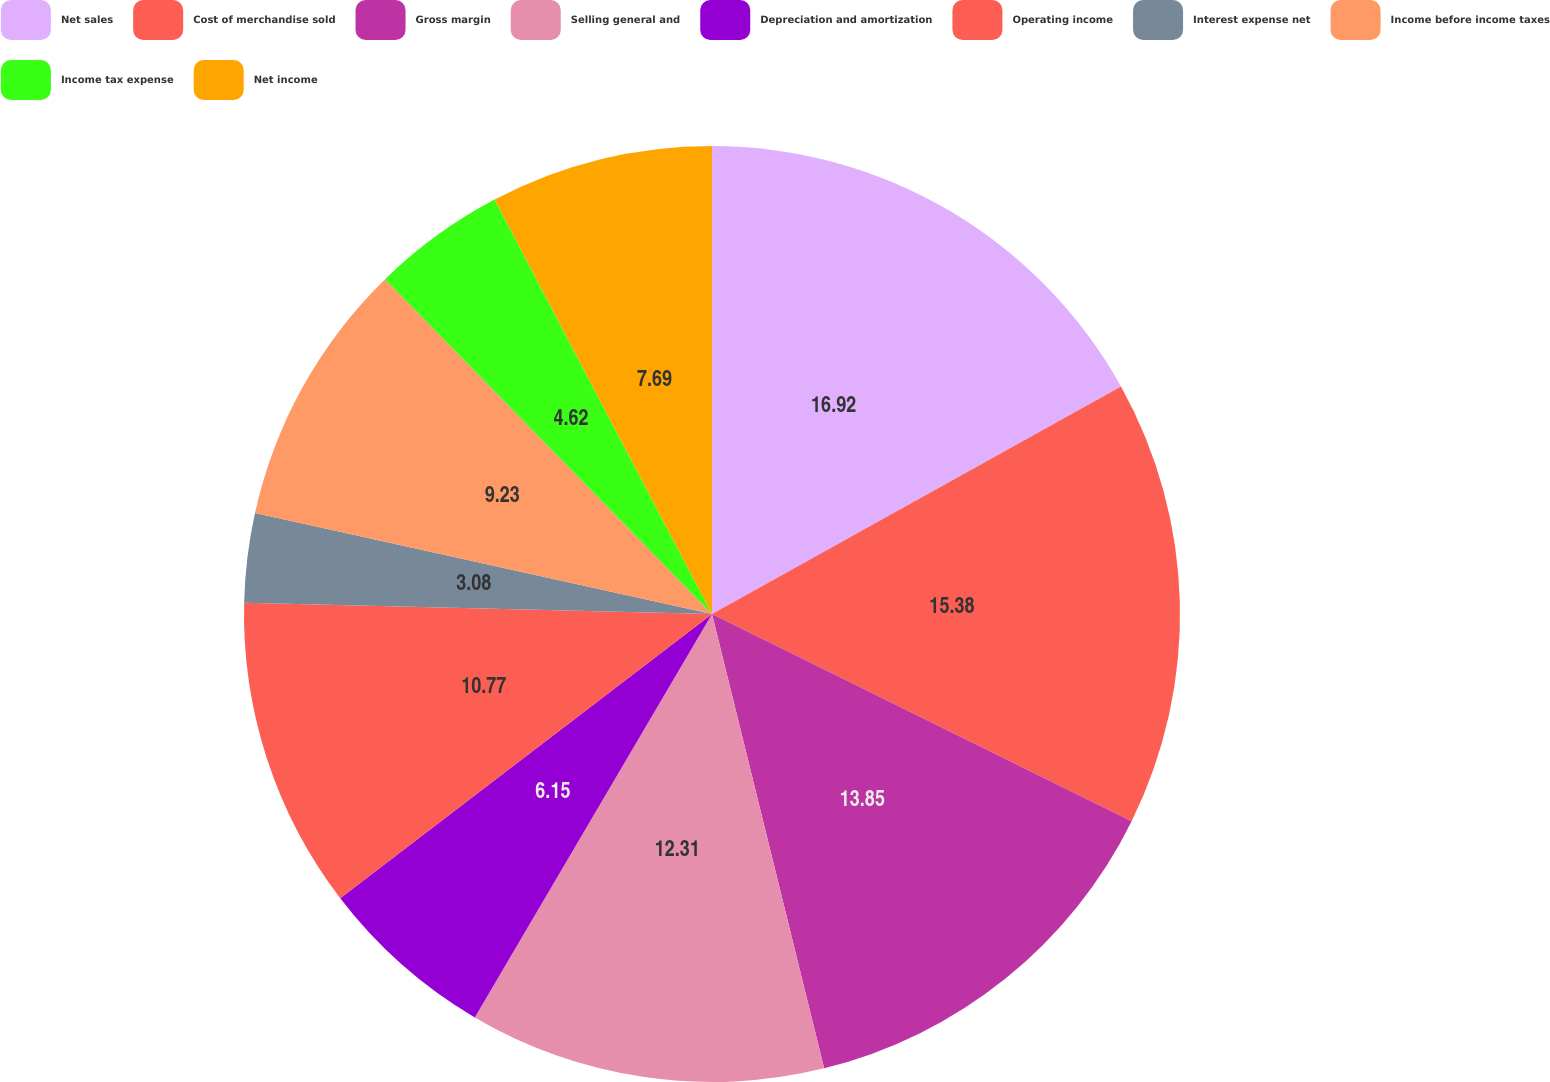<chart> <loc_0><loc_0><loc_500><loc_500><pie_chart><fcel>Net sales<fcel>Cost of merchandise sold<fcel>Gross margin<fcel>Selling general and<fcel>Depreciation and amortization<fcel>Operating income<fcel>Interest expense net<fcel>Income before income taxes<fcel>Income tax expense<fcel>Net income<nl><fcel>16.92%<fcel>15.38%<fcel>13.85%<fcel>12.31%<fcel>6.15%<fcel>10.77%<fcel>3.08%<fcel>9.23%<fcel>4.62%<fcel>7.69%<nl></chart> 